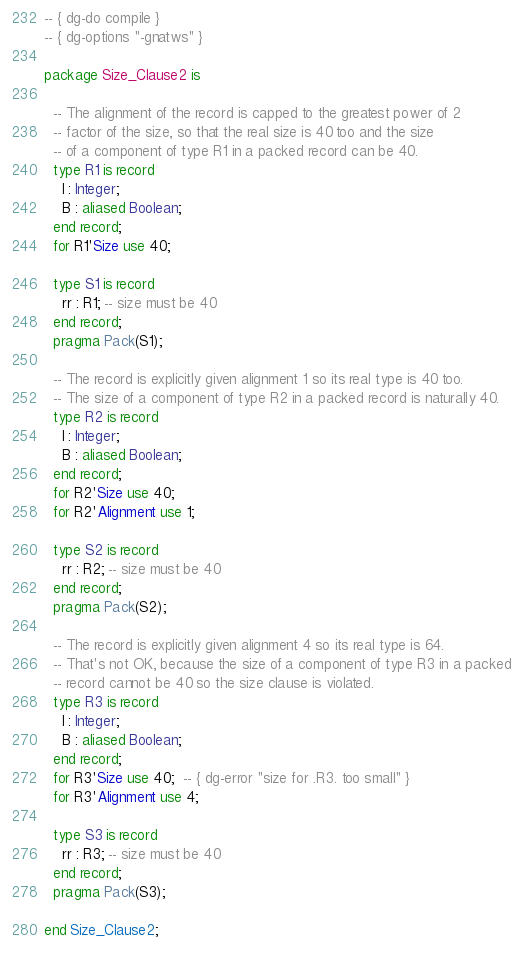<code> <loc_0><loc_0><loc_500><loc_500><_Ada_>-- { dg-do compile }
-- { dg-options "-gnatws" }

package Size_Clause2 is

  -- The alignment of the record is capped to the greatest power of 2
  -- factor of the size, so that the real size is 40 too and the size
  -- of a component of type R1 in a packed record can be 40.
  type R1 is record
    I : Integer;
    B : aliased Boolean;
  end record;
  for R1'Size use 40;

  type S1 is record
    rr : R1; -- size must be 40
  end record;
  pragma Pack(S1);

  -- The record is explicitly given alignment 1 so its real type is 40 too.
  -- The size of a component of type R2 in a packed record is naturally 40.
  type R2 is record
    I : Integer;
    B : aliased Boolean;
  end record;
  for R2'Size use 40;
  for R2'Alignment use 1;

  type S2 is record
    rr : R2; -- size must be 40
  end record;
  pragma Pack(S2);

  -- The record is explicitly given alignment 4 so its real type is 64.
  -- That's not OK, because the size of a component of type R3 in a packed
  -- record cannot be 40 so the size clause is violated.
  type R3 is record
    I : Integer;
    B : aliased Boolean;
  end record;
  for R3'Size use 40;  -- { dg-error "size for .R3. too small" }
  for R3'Alignment use 4;

  type S3 is record
    rr : R3; -- size must be 40
  end record;
  pragma Pack(S3);

end Size_Clause2;
</code> 